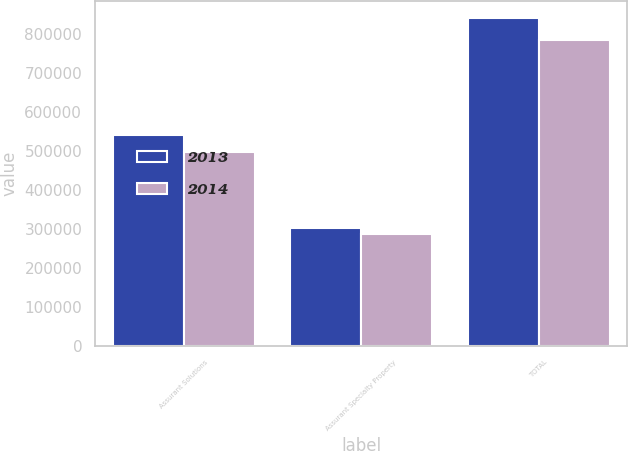Convert chart to OTSL. <chart><loc_0><loc_0><loc_500><loc_500><stacked_bar_chart><ecel><fcel>Assurant Solutions<fcel>Assurant Specialty Property<fcel>TOTAL<nl><fcel>2013<fcel>539653<fcel>301586<fcel>841239<nl><fcel>2014<fcel>496201<fcel>288360<fcel>784561<nl></chart> 